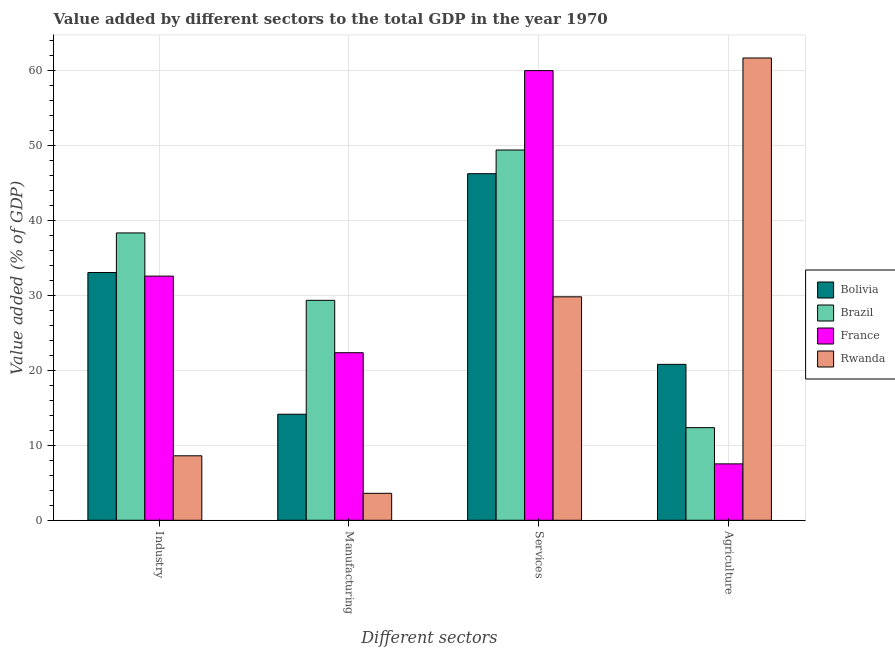How many groups of bars are there?
Ensure brevity in your answer.  4. Are the number of bars per tick equal to the number of legend labels?
Provide a short and direct response. Yes. How many bars are there on the 1st tick from the left?
Offer a very short reply. 4. What is the label of the 1st group of bars from the left?
Provide a succinct answer. Industry. What is the value added by manufacturing sector in Rwanda?
Ensure brevity in your answer.  3.59. Across all countries, what is the maximum value added by manufacturing sector?
Your answer should be compact. 29.32. Across all countries, what is the minimum value added by services sector?
Make the answer very short. 29.79. In which country was the value added by agricultural sector maximum?
Give a very brief answer. Rwanda. In which country was the value added by industrial sector minimum?
Your answer should be compact. Rwanda. What is the total value added by agricultural sector in the graph?
Keep it short and to the point. 102.27. What is the difference between the value added by industrial sector in France and that in Rwanda?
Your response must be concise. 23.95. What is the difference between the value added by industrial sector in Bolivia and the value added by manufacturing sector in Rwanda?
Your response must be concise. 29.43. What is the average value added by manufacturing sector per country?
Your answer should be compact. 17.34. What is the difference between the value added by services sector and value added by agricultural sector in France?
Your answer should be very brief. 52.42. What is the ratio of the value added by manufacturing sector in Brazil to that in Rwanda?
Your answer should be compact. 8.16. Is the value added by industrial sector in Rwanda less than that in Bolivia?
Your response must be concise. Yes. What is the difference between the highest and the second highest value added by services sector?
Offer a terse response. 10.58. What is the difference between the highest and the lowest value added by industrial sector?
Your answer should be compact. 29.71. Is the sum of the value added by manufacturing sector in France and Bolivia greater than the maximum value added by industrial sector across all countries?
Your answer should be very brief. No. Is it the case that in every country, the sum of the value added by agricultural sector and value added by manufacturing sector is greater than the sum of value added by industrial sector and value added by services sector?
Your answer should be very brief. No. What does the 4th bar from the right in Agriculture represents?
Give a very brief answer. Bolivia. Are all the bars in the graph horizontal?
Your answer should be very brief. No. What is the difference between two consecutive major ticks on the Y-axis?
Provide a succinct answer. 10. How many legend labels are there?
Offer a terse response. 4. How are the legend labels stacked?
Your response must be concise. Vertical. What is the title of the graph?
Your response must be concise. Value added by different sectors to the total GDP in the year 1970. What is the label or title of the X-axis?
Offer a terse response. Different sectors. What is the label or title of the Y-axis?
Offer a very short reply. Value added (% of GDP). What is the Value added (% of GDP) of Bolivia in Industry?
Offer a terse response. 33.02. What is the Value added (% of GDP) in Brazil in Industry?
Your response must be concise. 38.3. What is the Value added (% of GDP) in France in Industry?
Provide a succinct answer. 32.54. What is the Value added (% of GDP) in Rwanda in Industry?
Provide a short and direct response. 8.59. What is the Value added (% of GDP) in Bolivia in Manufacturing?
Ensure brevity in your answer.  14.13. What is the Value added (% of GDP) of Brazil in Manufacturing?
Ensure brevity in your answer.  29.32. What is the Value added (% of GDP) of France in Manufacturing?
Keep it short and to the point. 22.33. What is the Value added (% of GDP) in Rwanda in Manufacturing?
Make the answer very short. 3.59. What is the Value added (% of GDP) of Bolivia in Services?
Offer a terse response. 46.2. What is the Value added (% of GDP) in Brazil in Services?
Provide a succinct answer. 49.35. What is the Value added (% of GDP) in France in Services?
Ensure brevity in your answer.  59.94. What is the Value added (% of GDP) of Rwanda in Services?
Provide a succinct answer. 29.79. What is the Value added (% of GDP) of Bolivia in Agriculture?
Your answer should be very brief. 20.78. What is the Value added (% of GDP) in Brazil in Agriculture?
Provide a succinct answer. 12.35. What is the Value added (% of GDP) of France in Agriculture?
Your response must be concise. 7.52. What is the Value added (% of GDP) in Rwanda in Agriculture?
Give a very brief answer. 61.62. Across all Different sectors, what is the maximum Value added (% of GDP) of Bolivia?
Your answer should be compact. 46.2. Across all Different sectors, what is the maximum Value added (% of GDP) in Brazil?
Ensure brevity in your answer.  49.35. Across all Different sectors, what is the maximum Value added (% of GDP) in France?
Provide a short and direct response. 59.94. Across all Different sectors, what is the maximum Value added (% of GDP) in Rwanda?
Your response must be concise. 61.62. Across all Different sectors, what is the minimum Value added (% of GDP) in Bolivia?
Ensure brevity in your answer.  14.13. Across all Different sectors, what is the minimum Value added (% of GDP) in Brazil?
Your response must be concise. 12.35. Across all Different sectors, what is the minimum Value added (% of GDP) in France?
Give a very brief answer. 7.52. Across all Different sectors, what is the minimum Value added (% of GDP) of Rwanda?
Make the answer very short. 3.59. What is the total Value added (% of GDP) in Bolivia in the graph?
Ensure brevity in your answer.  114.13. What is the total Value added (% of GDP) of Brazil in the graph?
Your response must be concise. 129.32. What is the total Value added (% of GDP) in France in the graph?
Provide a short and direct response. 122.33. What is the total Value added (% of GDP) of Rwanda in the graph?
Give a very brief answer. 103.59. What is the difference between the Value added (% of GDP) of Bolivia in Industry and that in Manufacturing?
Provide a succinct answer. 18.89. What is the difference between the Value added (% of GDP) in Brazil in Industry and that in Manufacturing?
Offer a terse response. 8.98. What is the difference between the Value added (% of GDP) of France in Industry and that in Manufacturing?
Provide a short and direct response. 10.21. What is the difference between the Value added (% of GDP) in Rwanda in Industry and that in Manufacturing?
Your answer should be very brief. 5. What is the difference between the Value added (% of GDP) in Bolivia in Industry and that in Services?
Keep it short and to the point. -13.17. What is the difference between the Value added (% of GDP) of Brazil in Industry and that in Services?
Ensure brevity in your answer.  -11.05. What is the difference between the Value added (% of GDP) in France in Industry and that in Services?
Offer a very short reply. -27.39. What is the difference between the Value added (% of GDP) of Rwanda in Industry and that in Services?
Offer a terse response. -21.19. What is the difference between the Value added (% of GDP) of Bolivia in Industry and that in Agriculture?
Provide a succinct answer. 12.24. What is the difference between the Value added (% of GDP) in Brazil in Industry and that in Agriculture?
Your response must be concise. 25.96. What is the difference between the Value added (% of GDP) in France in Industry and that in Agriculture?
Offer a very short reply. 25.03. What is the difference between the Value added (% of GDP) of Rwanda in Industry and that in Agriculture?
Your response must be concise. -53.02. What is the difference between the Value added (% of GDP) in Bolivia in Manufacturing and that in Services?
Give a very brief answer. -32.06. What is the difference between the Value added (% of GDP) in Brazil in Manufacturing and that in Services?
Give a very brief answer. -20.04. What is the difference between the Value added (% of GDP) in France in Manufacturing and that in Services?
Make the answer very short. -37.6. What is the difference between the Value added (% of GDP) in Rwanda in Manufacturing and that in Services?
Offer a very short reply. -26.19. What is the difference between the Value added (% of GDP) in Bolivia in Manufacturing and that in Agriculture?
Offer a very short reply. -6.65. What is the difference between the Value added (% of GDP) in Brazil in Manufacturing and that in Agriculture?
Your answer should be very brief. 16.97. What is the difference between the Value added (% of GDP) in France in Manufacturing and that in Agriculture?
Provide a succinct answer. 14.82. What is the difference between the Value added (% of GDP) of Rwanda in Manufacturing and that in Agriculture?
Your answer should be compact. -58.03. What is the difference between the Value added (% of GDP) in Bolivia in Services and that in Agriculture?
Offer a terse response. 25.41. What is the difference between the Value added (% of GDP) in Brazil in Services and that in Agriculture?
Provide a succinct answer. 37.01. What is the difference between the Value added (% of GDP) in France in Services and that in Agriculture?
Give a very brief answer. 52.42. What is the difference between the Value added (% of GDP) of Rwanda in Services and that in Agriculture?
Your response must be concise. -31.83. What is the difference between the Value added (% of GDP) of Bolivia in Industry and the Value added (% of GDP) of Brazil in Manufacturing?
Offer a terse response. 3.7. What is the difference between the Value added (% of GDP) in Bolivia in Industry and the Value added (% of GDP) in France in Manufacturing?
Give a very brief answer. 10.69. What is the difference between the Value added (% of GDP) of Bolivia in Industry and the Value added (% of GDP) of Rwanda in Manufacturing?
Make the answer very short. 29.43. What is the difference between the Value added (% of GDP) of Brazil in Industry and the Value added (% of GDP) of France in Manufacturing?
Ensure brevity in your answer.  15.97. What is the difference between the Value added (% of GDP) in Brazil in Industry and the Value added (% of GDP) in Rwanda in Manufacturing?
Give a very brief answer. 34.71. What is the difference between the Value added (% of GDP) of France in Industry and the Value added (% of GDP) of Rwanda in Manufacturing?
Your response must be concise. 28.95. What is the difference between the Value added (% of GDP) of Bolivia in Industry and the Value added (% of GDP) of Brazil in Services?
Provide a succinct answer. -16.33. What is the difference between the Value added (% of GDP) in Bolivia in Industry and the Value added (% of GDP) in France in Services?
Give a very brief answer. -26.92. What is the difference between the Value added (% of GDP) in Bolivia in Industry and the Value added (% of GDP) in Rwanda in Services?
Give a very brief answer. 3.24. What is the difference between the Value added (% of GDP) of Brazil in Industry and the Value added (% of GDP) of France in Services?
Provide a succinct answer. -21.64. What is the difference between the Value added (% of GDP) of Brazil in Industry and the Value added (% of GDP) of Rwanda in Services?
Offer a very short reply. 8.51. What is the difference between the Value added (% of GDP) of France in Industry and the Value added (% of GDP) of Rwanda in Services?
Provide a succinct answer. 2.76. What is the difference between the Value added (% of GDP) in Bolivia in Industry and the Value added (% of GDP) in Brazil in Agriculture?
Give a very brief answer. 20.68. What is the difference between the Value added (% of GDP) of Bolivia in Industry and the Value added (% of GDP) of France in Agriculture?
Provide a succinct answer. 25.5. What is the difference between the Value added (% of GDP) of Bolivia in Industry and the Value added (% of GDP) of Rwanda in Agriculture?
Offer a terse response. -28.6. What is the difference between the Value added (% of GDP) in Brazil in Industry and the Value added (% of GDP) in France in Agriculture?
Give a very brief answer. 30.78. What is the difference between the Value added (% of GDP) in Brazil in Industry and the Value added (% of GDP) in Rwanda in Agriculture?
Your answer should be compact. -23.32. What is the difference between the Value added (% of GDP) of France in Industry and the Value added (% of GDP) of Rwanda in Agriculture?
Your answer should be very brief. -29.07. What is the difference between the Value added (% of GDP) in Bolivia in Manufacturing and the Value added (% of GDP) in Brazil in Services?
Give a very brief answer. -35.22. What is the difference between the Value added (% of GDP) in Bolivia in Manufacturing and the Value added (% of GDP) in France in Services?
Offer a very short reply. -45.8. What is the difference between the Value added (% of GDP) of Bolivia in Manufacturing and the Value added (% of GDP) of Rwanda in Services?
Give a very brief answer. -15.65. What is the difference between the Value added (% of GDP) of Brazil in Manufacturing and the Value added (% of GDP) of France in Services?
Offer a terse response. -30.62. What is the difference between the Value added (% of GDP) in Brazil in Manufacturing and the Value added (% of GDP) in Rwanda in Services?
Your answer should be compact. -0.47. What is the difference between the Value added (% of GDP) in France in Manufacturing and the Value added (% of GDP) in Rwanda in Services?
Ensure brevity in your answer.  -7.45. What is the difference between the Value added (% of GDP) of Bolivia in Manufacturing and the Value added (% of GDP) of Brazil in Agriculture?
Give a very brief answer. 1.79. What is the difference between the Value added (% of GDP) in Bolivia in Manufacturing and the Value added (% of GDP) in France in Agriculture?
Offer a very short reply. 6.62. What is the difference between the Value added (% of GDP) in Bolivia in Manufacturing and the Value added (% of GDP) in Rwanda in Agriculture?
Offer a terse response. -47.48. What is the difference between the Value added (% of GDP) in Brazil in Manufacturing and the Value added (% of GDP) in France in Agriculture?
Your response must be concise. 21.8. What is the difference between the Value added (% of GDP) of Brazil in Manufacturing and the Value added (% of GDP) of Rwanda in Agriculture?
Provide a short and direct response. -32.3. What is the difference between the Value added (% of GDP) of France in Manufacturing and the Value added (% of GDP) of Rwanda in Agriculture?
Provide a succinct answer. -39.28. What is the difference between the Value added (% of GDP) of Bolivia in Services and the Value added (% of GDP) of Brazil in Agriculture?
Your answer should be very brief. 33.85. What is the difference between the Value added (% of GDP) of Bolivia in Services and the Value added (% of GDP) of France in Agriculture?
Offer a very short reply. 38.68. What is the difference between the Value added (% of GDP) in Bolivia in Services and the Value added (% of GDP) in Rwanda in Agriculture?
Make the answer very short. -15.42. What is the difference between the Value added (% of GDP) of Brazil in Services and the Value added (% of GDP) of France in Agriculture?
Provide a short and direct response. 41.84. What is the difference between the Value added (% of GDP) of Brazil in Services and the Value added (% of GDP) of Rwanda in Agriculture?
Offer a terse response. -12.26. What is the difference between the Value added (% of GDP) of France in Services and the Value added (% of GDP) of Rwanda in Agriculture?
Provide a succinct answer. -1.68. What is the average Value added (% of GDP) in Bolivia per Different sectors?
Provide a short and direct response. 28.53. What is the average Value added (% of GDP) in Brazil per Different sectors?
Provide a short and direct response. 32.33. What is the average Value added (% of GDP) in France per Different sectors?
Provide a short and direct response. 30.58. What is the average Value added (% of GDP) of Rwanda per Different sectors?
Your answer should be compact. 25.9. What is the difference between the Value added (% of GDP) of Bolivia and Value added (% of GDP) of Brazil in Industry?
Your answer should be very brief. -5.28. What is the difference between the Value added (% of GDP) of Bolivia and Value added (% of GDP) of France in Industry?
Offer a very short reply. 0.48. What is the difference between the Value added (% of GDP) in Bolivia and Value added (% of GDP) in Rwanda in Industry?
Ensure brevity in your answer.  24.43. What is the difference between the Value added (% of GDP) of Brazil and Value added (% of GDP) of France in Industry?
Provide a short and direct response. 5.76. What is the difference between the Value added (% of GDP) in Brazil and Value added (% of GDP) in Rwanda in Industry?
Offer a very short reply. 29.71. What is the difference between the Value added (% of GDP) of France and Value added (% of GDP) of Rwanda in Industry?
Your answer should be very brief. 23.95. What is the difference between the Value added (% of GDP) of Bolivia and Value added (% of GDP) of Brazil in Manufacturing?
Offer a terse response. -15.18. What is the difference between the Value added (% of GDP) of Bolivia and Value added (% of GDP) of France in Manufacturing?
Your answer should be compact. -8.2. What is the difference between the Value added (% of GDP) in Bolivia and Value added (% of GDP) in Rwanda in Manufacturing?
Your answer should be very brief. 10.54. What is the difference between the Value added (% of GDP) of Brazil and Value added (% of GDP) of France in Manufacturing?
Your answer should be very brief. 6.98. What is the difference between the Value added (% of GDP) in Brazil and Value added (% of GDP) in Rwanda in Manufacturing?
Your answer should be compact. 25.72. What is the difference between the Value added (% of GDP) of France and Value added (% of GDP) of Rwanda in Manufacturing?
Your answer should be very brief. 18.74. What is the difference between the Value added (% of GDP) in Bolivia and Value added (% of GDP) in Brazil in Services?
Your response must be concise. -3.16. What is the difference between the Value added (% of GDP) in Bolivia and Value added (% of GDP) in France in Services?
Ensure brevity in your answer.  -13.74. What is the difference between the Value added (% of GDP) in Bolivia and Value added (% of GDP) in Rwanda in Services?
Your answer should be compact. 16.41. What is the difference between the Value added (% of GDP) of Brazil and Value added (% of GDP) of France in Services?
Offer a very short reply. -10.58. What is the difference between the Value added (% of GDP) in Brazil and Value added (% of GDP) in Rwanda in Services?
Give a very brief answer. 19.57. What is the difference between the Value added (% of GDP) of France and Value added (% of GDP) of Rwanda in Services?
Ensure brevity in your answer.  30.15. What is the difference between the Value added (% of GDP) in Bolivia and Value added (% of GDP) in Brazil in Agriculture?
Offer a very short reply. 8.44. What is the difference between the Value added (% of GDP) of Bolivia and Value added (% of GDP) of France in Agriculture?
Make the answer very short. 13.27. What is the difference between the Value added (% of GDP) in Bolivia and Value added (% of GDP) in Rwanda in Agriculture?
Offer a terse response. -40.84. What is the difference between the Value added (% of GDP) of Brazil and Value added (% of GDP) of France in Agriculture?
Your answer should be compact. 4.83. What is the difference between the Value added (% of GDP) in Brazil and Value added (% of GDP) in Rwanda in Agriculture?
Your answer should be compact. -49.27. What is the difference between the Value added (% of GDP) of France and Value added (% of GDP) of Rwanda in Agriculture?
Give a very brief answer. -54.1. What is the ratio of the Value added (% of GDP) of Bolivia in Industry to that in Manufacturing?
Offer a terse response. 2.34. What is the ratio of the Value added (% of GDP) of Brazil in Industry to that in Manufacturing?
Make the answer very short. 1.31. What is the ratio of the Value added (% of GDP) in France in Industry to that in Manufacturing?
Ensure brevity in your answer.  1.46. What is the ratio of the Value added (% of GDP) of Rwanda in Industry to that in Manufacturing?
Ensure brevity in your answer.  2.39. What is the ratio of the Value added (% of GDP) of Bolivia in Industry to that in Services?
Keep it short and to the point. 0.71. What is the ratio of the Value added (% of GDP) in Brazil in Industry to that in Services?
Provide a succinct answer. 0.78. What is the ratio of the Value added (% of GDP) of France in Industry to that in Services?
Offer a terse response. 0.54. What is the ratio of the Value added (% of GDP) in Rwanda in Industry to that in Services?
Keep it short and to the point. 0.29. What is the ratio of the Value added (% of GDP) of Bolivia in Industry to that in Agriculture?
Your answer should be compact. 1.59. What is the ratio of the Value added (% of GDP) of Brazil in Industry to that in Agriculture?
Offer a terse response. 3.1. What is the ratio of the Value added (% of GDP) in France in Industry to that in Agriculture?
Give a very brief answer. 4.33. What is the ratio of the Value added (% of GDP) of Rwanda in Industry to that in Agriculture?
Give a very brief answer. 0.14. What is the ratio of the Value added (% of GDP) of Bolivia in Manufacturing to that in Services?
Give a very brief answer. 0.31. What is the ratio of the Value added (% of GDP) in Brazil in Manufacturing to that in Services?
Ensure brevity in your answer.  0.59. What is the ratio of the Value added (% of GDP) of France in Manufacturing to that in Services?
Make the answer very short. 0.37. What is the ratio of the Value added (% of GDP) of Rwanda in Manufacturing to that in Services?
Offer a very short reply. 0.12. What is the ratio of the Value added (% of GDP) of Bolivia in Manufacturing to that in Agriculture?
Keep it short and to the point. 0.68. What is the ratio of the Value added (% of GDP) in Brazil in Manufacturing to that in Agriculture?
Your response must be concise. 2.37. What is the ratio of the Value added (% of GDP) of France in Manufacturing to that in Agriculture?
Your answer should be very brief. 2.97. What is the ratio of the Value added (% of GDP) in Rwanda in Manufacturing to that in Agriculture?
Keep it short and to the point. 0.06. What is the ratio of the Value added (% of GDP) of Bolivia in Services to that in Agriculture?
Your answer should be compact. 2.22. What is the ratio of the Value added (% of GDP) in Brazil in Services to that in Agriculture?
Your answer should be compact. 4. What is the ratio of the Value added (% of GDP) of France in Services to that in Agriculture?
Your answer should be very brief. 7.97. What is the ratio of the Value added (% of GDP) of Rwanda in Services to that in Agriculture?
Give a very brief answer. 0.48. What is the difference between the highest and the second highest Value added (% of GDP) of Bolivia?
Offer a terse response. 13.17. What is the difference between the highest and the second highest Value added (% of GDP) of Brazil?
Give a very brief answer. 11.05. What is the difference between the highest and the second highest Value added (% of GDP) in France?
Give a very brief answer. 27.39. What is the difference between the highest and the second highest Value added (% of GDP) in Rwanda?
Ensure brevity in your answer.  31.83. What is the difference between the highest and the lowest Value added (% of GDP) in Bolivia?
Your answer should be very brief. 32.06. What is the difference between the highest and the lowest Value added (% of GDP) in Brazil?
Offer a very short reply. 37.01. What is the difference between the highest and the lowest Value added (% of GDP) in France?
Keep it short and to the point. 52.42. What is the difference between the highest and the lowest Value added (% of GDP) of Rwanda?
Your response must be concise. 58.03. 